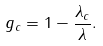<formula> <loc_0><loc_0><loc_500><loc_500>g _ { c } = 1 - \frac { \lambda _ { c } } { \lambda } .</formula> 